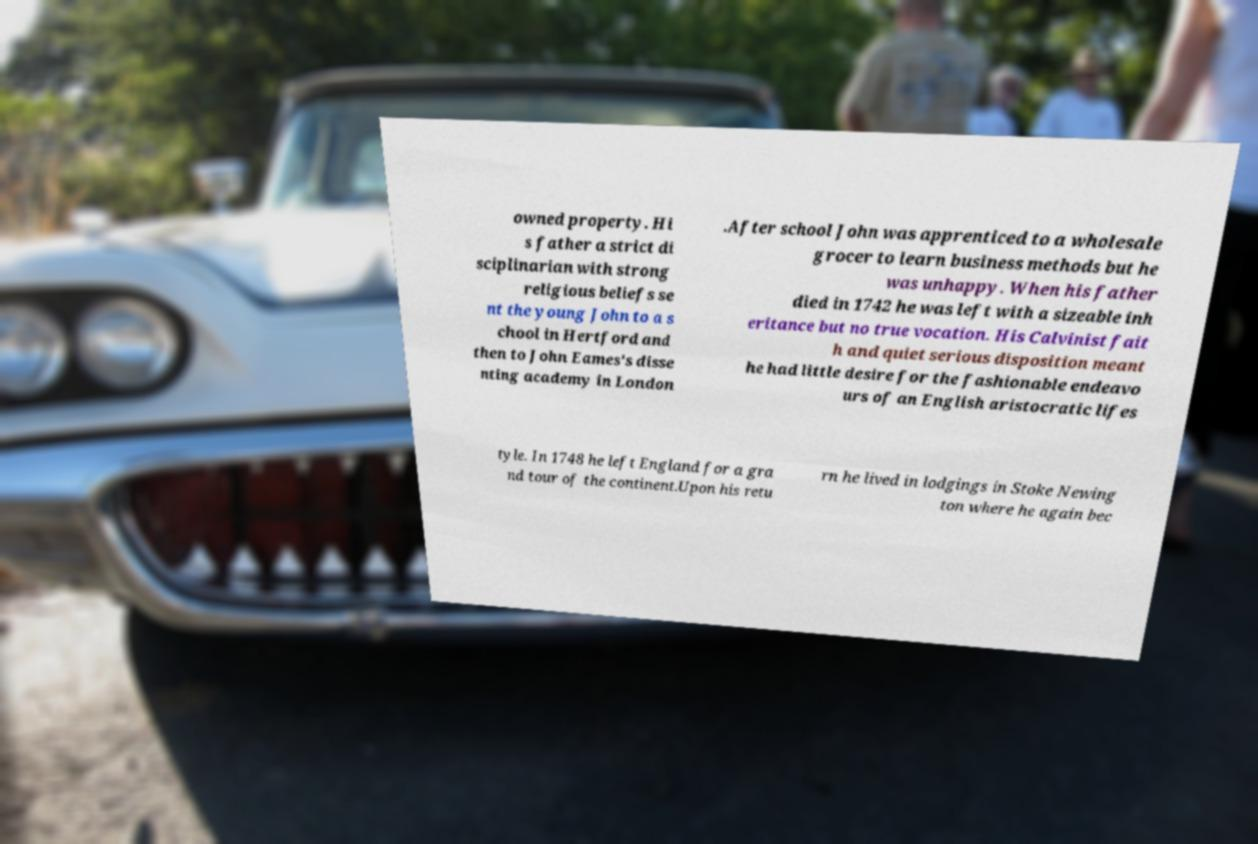Could you assist in decoding the text presented in this image and type it out clearly? owned property. Hi s father a strict di sciplinarian with strong religious beliefs se nt the young John to a s chool in Hertford and then to John Eames's disse nting academy in London .After school John was apprenticed to a wholesale grocer to learn business methods but he was unhappy. When his father died in 1742 he was left with a sizeable inh eritance but no true vocation. His Calvinist fait h and quiet serious disposition meant he had little desire for the fashionable endeavo urs of an English aristocratic lifes tyle. In 1748 he left England for a gra nd tour of the continent.Upon his retu rn he lived in lodgings in Stoke Newing ton where he again bec 